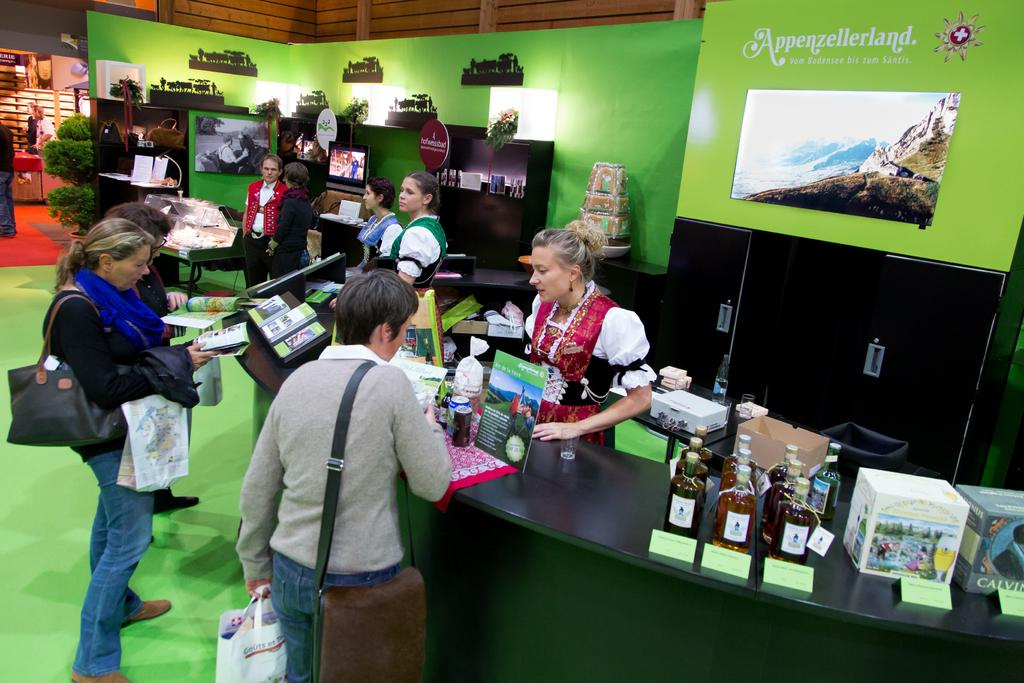What is the person in the image holding? The person is holding a camera. What can be seen in the background of the image? There is a tree in the background of the image. How many squares can be seen in the image? There are no squares present in the image. What type of weather is depicted in the image? The transcript does not mention any weather conditions, so we cannot determine if it is a rainstorm or not. 